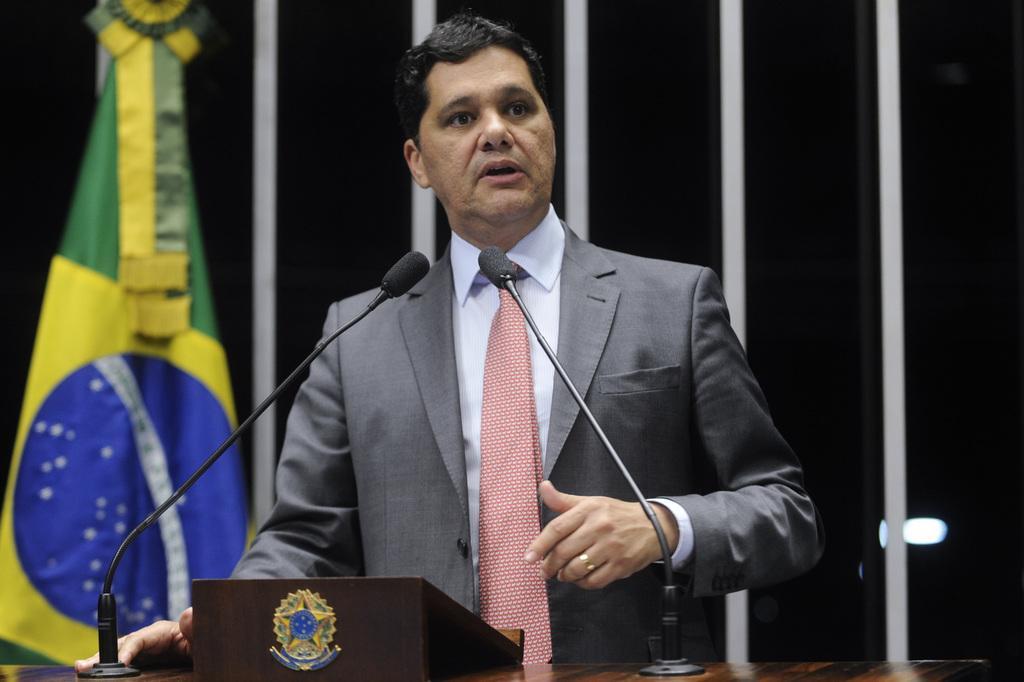How would you summarize this image in a sentence or two? In this picture there is a person wearing suit is standing and speaking in front of two mics and there is a flag in the background. 